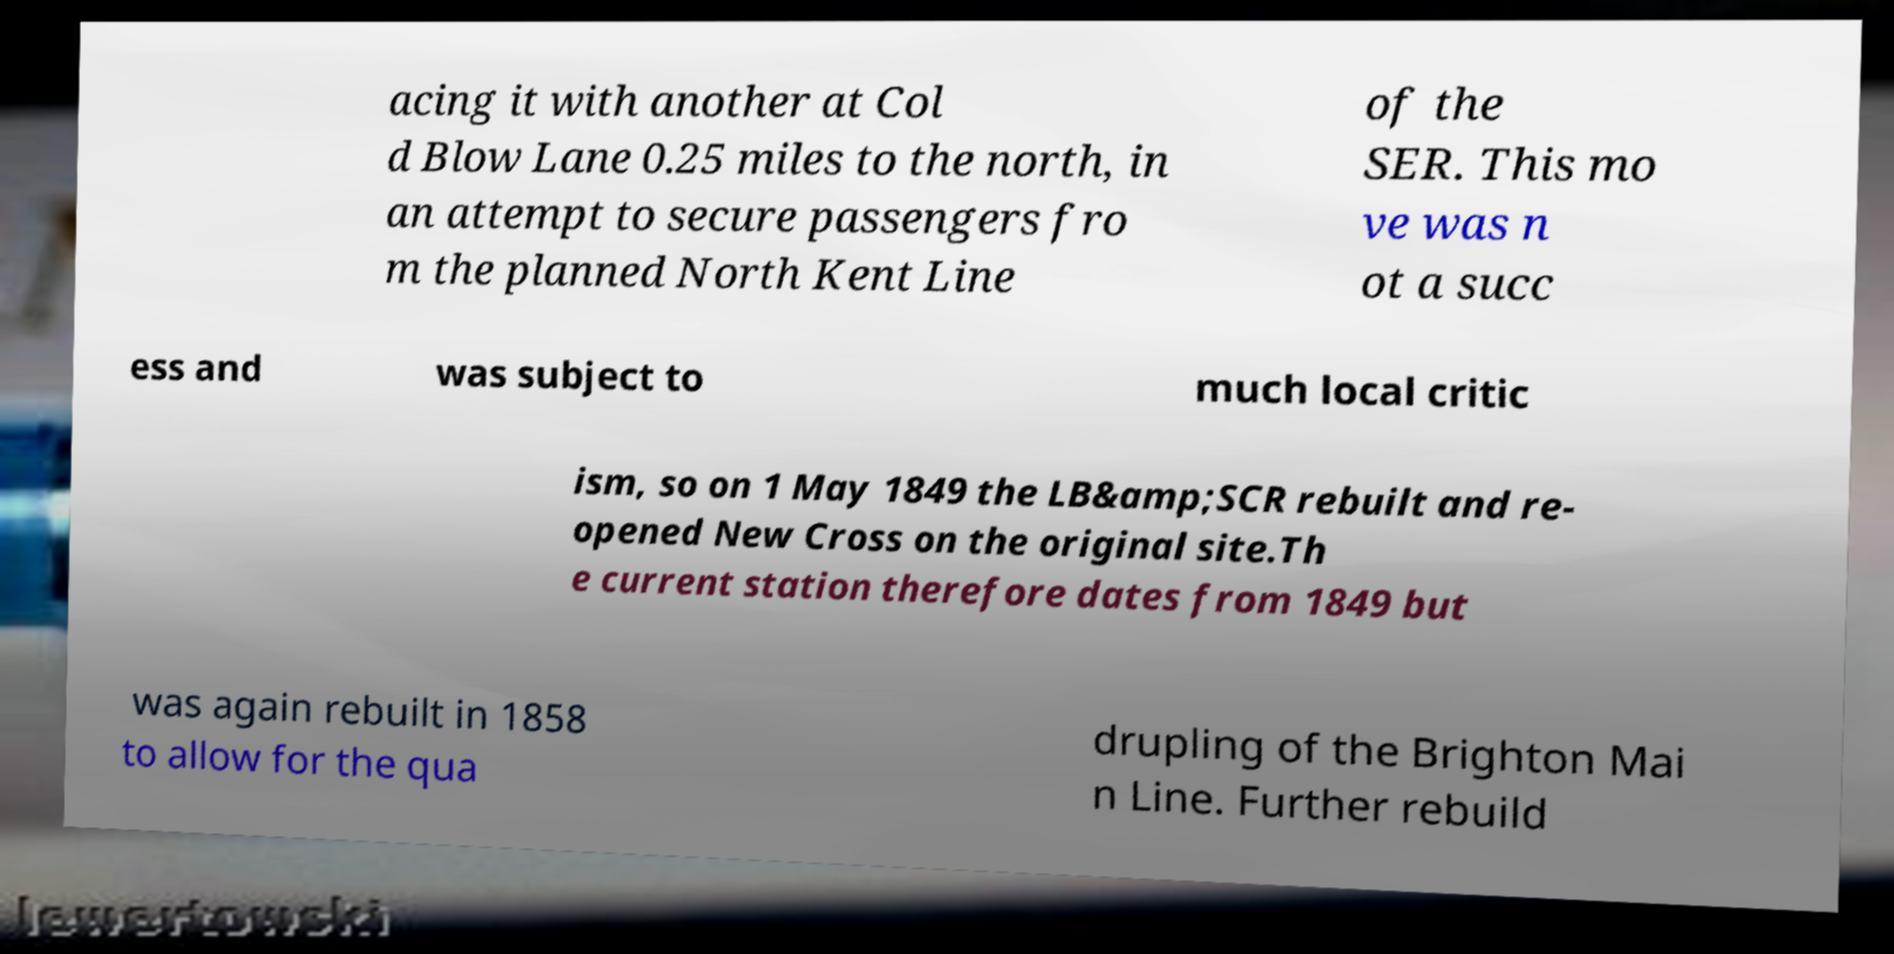Can you read and provide the text displayed in the image?This photo seems to have some interesting text. Can you extract and type it out for me? acing it with another at Col d Blow Lane 0.25 miles to the north, in an attempt to secure passengers fro m the planned North Kent Line of the SER. This mo ve was n ot a succ ess and was subject to much local critic ism, so on 1 May 1849 the LB&amp;SCR rebuilt and re- opened New Cross on the original site.Th e current station therefore dates from 1849 but was again rebuilt in 1858 to allow for the qua drupling of the Brighton Mai n Line. Further rebuild 